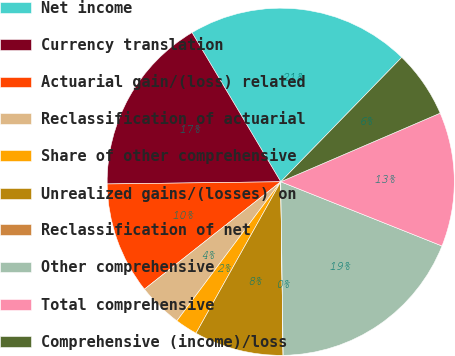Convert chart to OTSL. <chart><loc_0><loc_0><loc_500><loc_500><pie_chart><fcel>Net income<fcel>Currency translation<fcel>Actuarial gain/(loss) related<fcel>Reclassification of actuarial<fcel>Share of other comprehensive<fcel>Unrealized gains/(losses) on<fcel>Reclassification of net<fcel>Other comprehensive<fcel>Total comprehensive<fcel>Comprehensive (income)/loss<nl><fcel>20.82%<fcel>16.66%<fcel>10.42%<fcel>4.17%<fcel>2.09%<fcel>8.33%<fcel>0.01%<fcel>18.74%<fcel>12.5%<fcel>6.25%<nl></chart> 